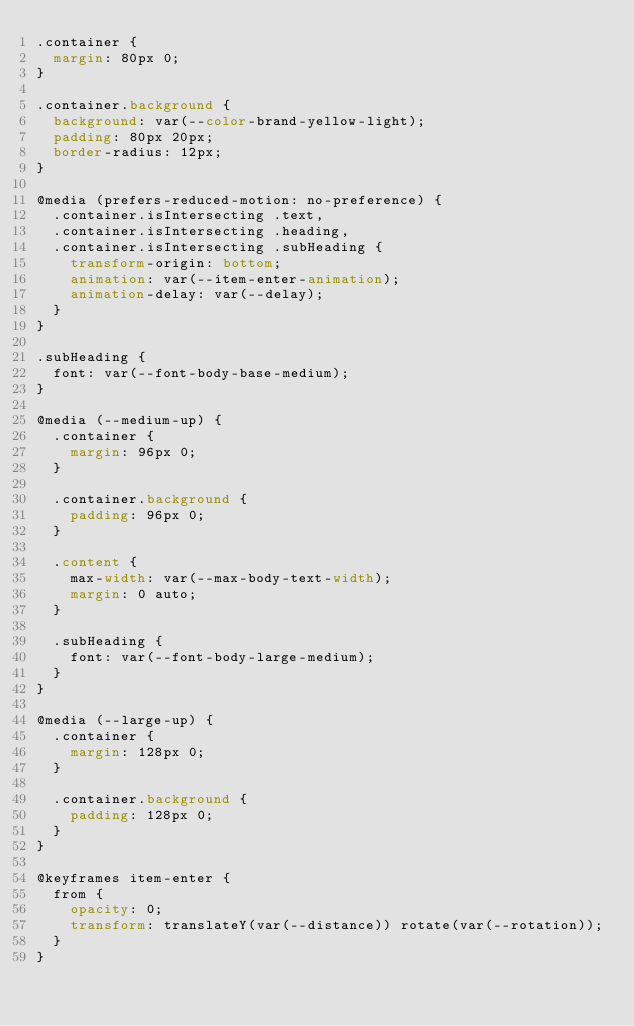Convert code to text. <code><loc_0><loc_0><loc_500><loc_500><_CSS_>.container {
  margin: 80px 0;
}

.container.background {
  background: var(--color-brand-yellow-light);
  padding: 80px 20px;
  border-radius: 12px;
}

@media (prefers-reduced-motion: no-preference) {
  .container.isIntersecting .text,
  .container.isIntersecting .heading,
  .container.isIntersecting .subHeading {
    transform-origin: bottom;
    animation: var(--item-enter-animation);
    animation-delay: var(--delay);
  }
}

.subHeading {
  font: var(--font-body-base-medium);
}

@media (--medium-up) {
  .container {
    margin: 96px 0;
  }

  .container.background {
    padding: 96px 0;
  }

  .content {
    max-width: var(--max-body-text-width);
    margin: 0 auto;
  }

  .subHeading {
    font: var(--font-body-large-medium);
  }
}

@media (--large-up) {
  .container {
    margin: 128px 0;
  }

  .container.background {
    padding: 128px 0;
  }
}

@keyframes item-enter {
  from {
    opacity: 0;
    transform: translateY(var(--distance)) rotate(var(--rotation));
  }
}
</code> 